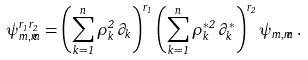Convert formula to latex. <formula><loc_0><loc_0><loc_500><loc_500>\psi _ { m , \widetilde { m } } ^ { r _ { 1 } r _ { 2 } } = \left ( \sum _ { k = 1 } ^ { n } \rho _ { k } ^ { 2 } \, \partial _ { k } \right ) ^ { r _ { 1 } } \left ( \sum _ { k = 1 } ^ { n } \rho _ { k } ^ { * 2 } \, \partial _ { k } ^ { * } \right ) ^ { r _ { 2 } } \psi _ { m , \widetilde { m } } \, .</formula> 